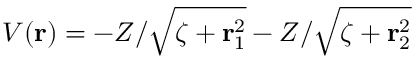Convert formula to latex. <formula><loc_0><loc_0><loc_500><loc_500>V ( r ) = - Z / \sqrt { \zeta + r _ { 1 } ^ { 2 } } - Z / \sqrt { \zeta + r _ { 2 } ^ { 2 } }</formula> 